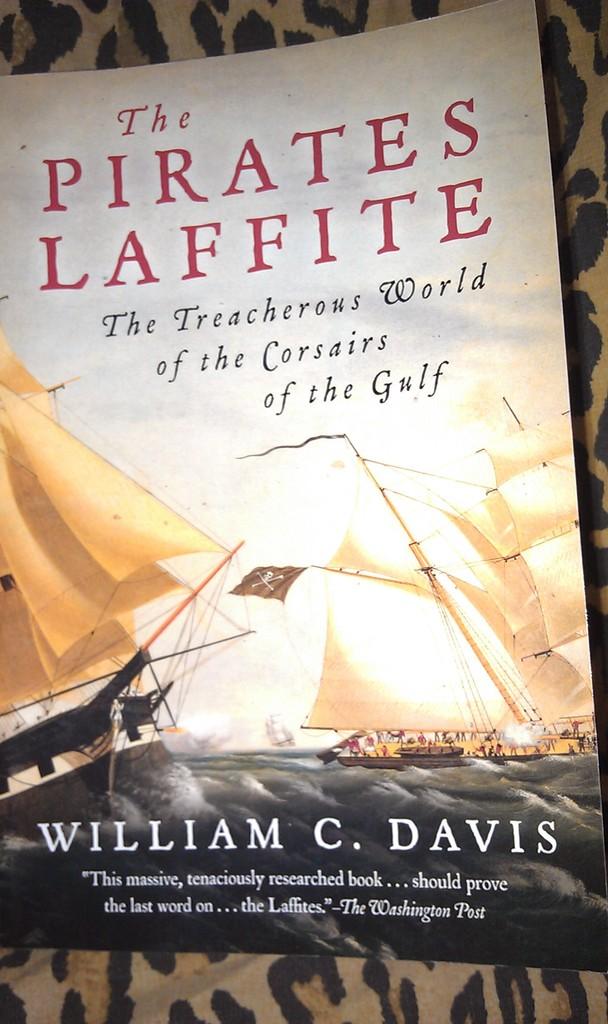Who wrote this novel?
Keep it short and to the point. William c. davis. 